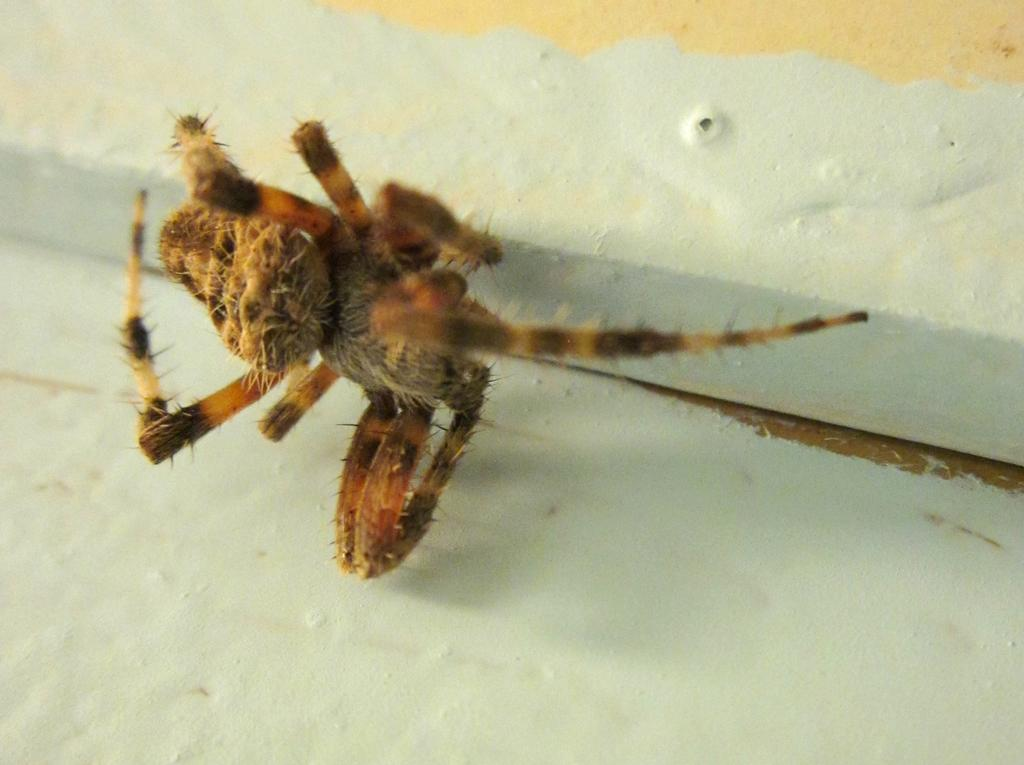What type of creature is present in the image? There is an insect in the image. Where is the insect located? The insect is on the wall. What type of dress is hanging on the shelf in the image? There is no dress or shelf present in the image; it only features an insect on the wall. 